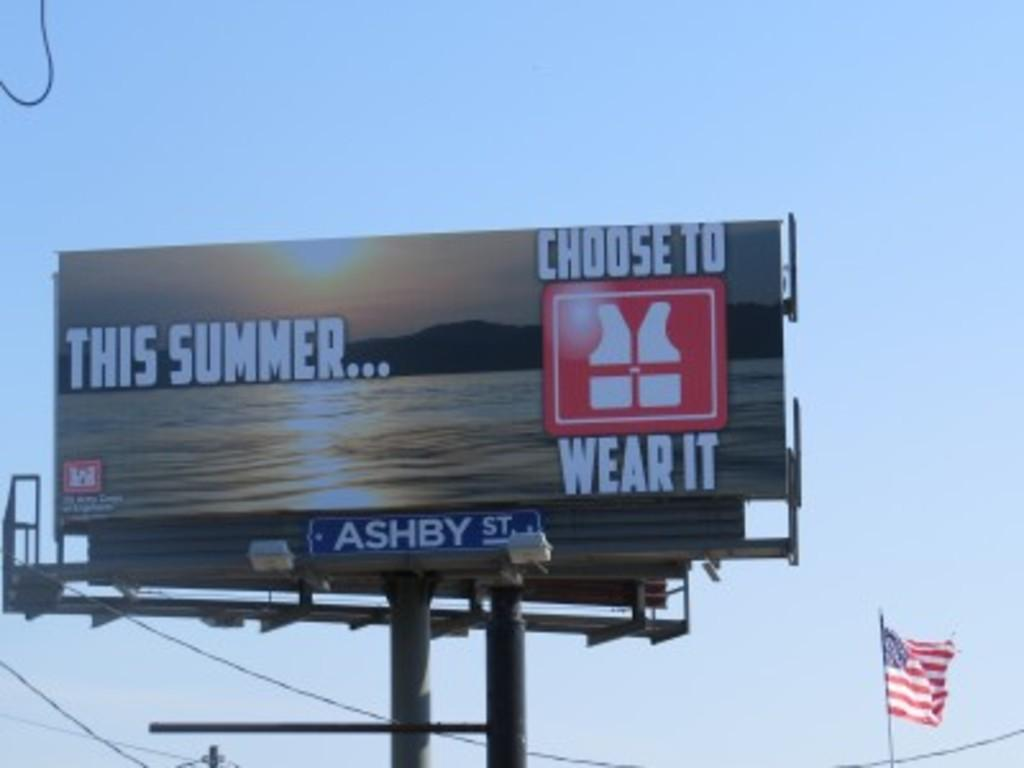<image>
Write a terse but informative summary of the picture. A blue sky is behind a sign that warns to wear life vests this summer. 